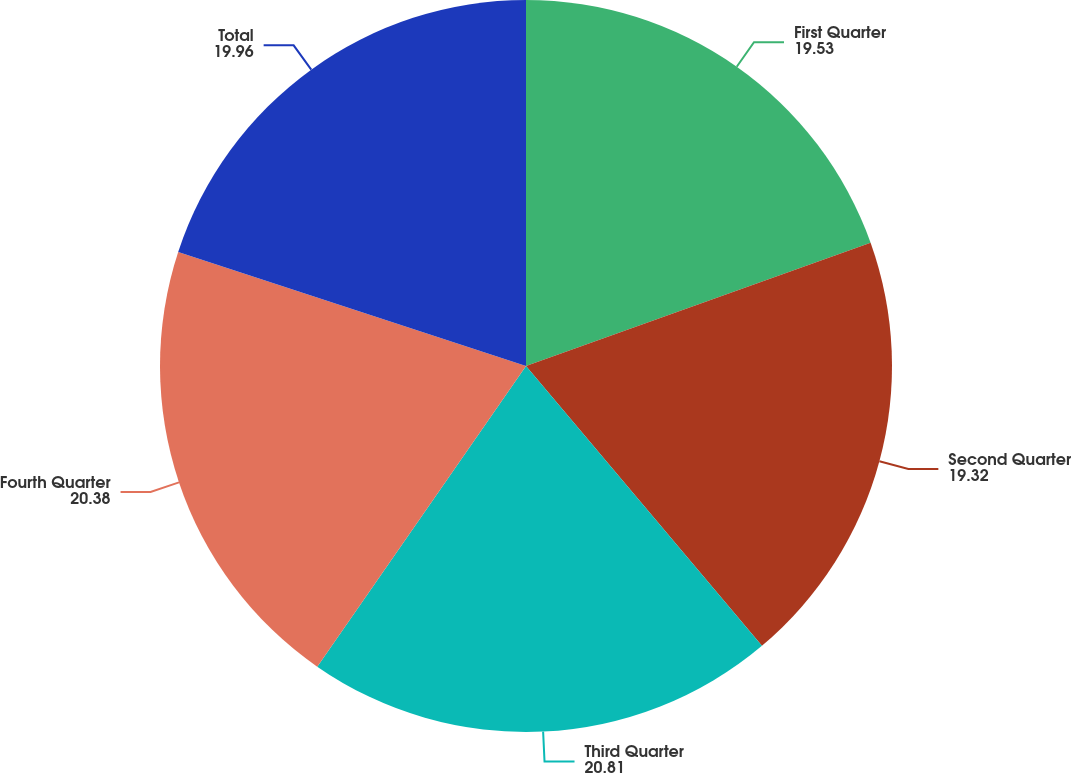Convert chart. <chart><loc_0><loc_0><loc_500><loc_500><pie_chart><fcel>First Quarter<fcel>Second Quarter<fcel>Third Quarter<fcel>Fourth Quarter<fcel>Total<nl><fcel>19.53%<fcel>19.32%<fcel>20.81%<fcel>20.38%<fcel>19.96%<nl></chart> 